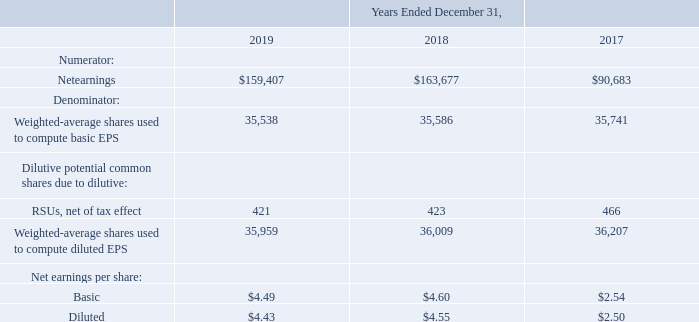Net Earnings Per Share (“EPS”)
Basic EPS is computed by dividing net earnings available to common stockholders by the weighted average number of common shares outstanding during each year. Diluted EPS is computed on the basis of the weighted average number of shares of common stock plus the effect of dilutive potential common shares outstanding during the period using the treasury stock method. Dilutive potential common shares include outstanding RSUs.
A reconciliation of the denominators of the basic and diluted EPS calculations follows (in thousands, except per share data):
In 2019, 2018 and 2017, approximately 42,000, 17,000 and 40,000, respectively, of our RSUs were not included in the diluted EPS calculations because their inclusion would have been anti-dilutive. These share-based awards could be dilutive in the future. In the year ended December 31, 2019, certain potential outstanding shares from convertible senior notes and warrants were not included in the diluted EPS calculations because their inclusion would have been anti-dilutive.
How is Basic EPS computed? By dividing net earnings available to common stockholders by the weighted average number of common shares outstanding during each year. How is Diluted EPS computed? On the basis of the weighted average number of shares of common stock plus the effect of dilutive potential common shares outstanding during the period using the treasury stock method. How much RSUs were not included in the diluted EPS calculations in 2019, 2018 and 2017 respectively? 42,000, 17,000, 40,000. What is the change in Net earnings between 2018 and 2019?
Answer scale should be: thousand. 159,407-163,677
Answer: -4270. What is the change in Weighted-average shares used to compute basic EPS from 2018 and 2019?
Answer scale should be: thousand. 35,538-35,586
Answer: -48. What is the average Net earnings for 2018 and 2019?
Answer scale should be: thousand. (159,407+163,677) / 2
Answer: 161542. 